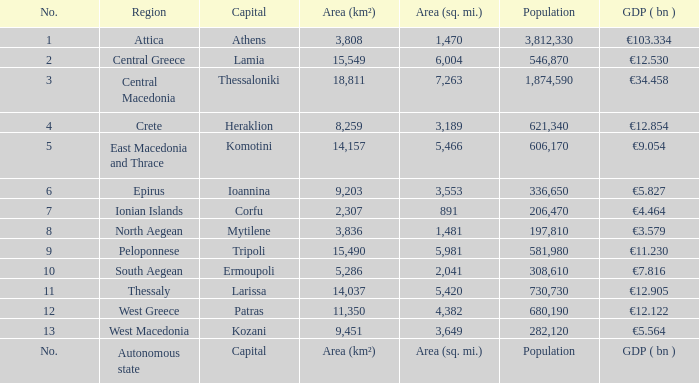What is the gdp (bn) where the principal city is the capital? GDP ( bn ). 